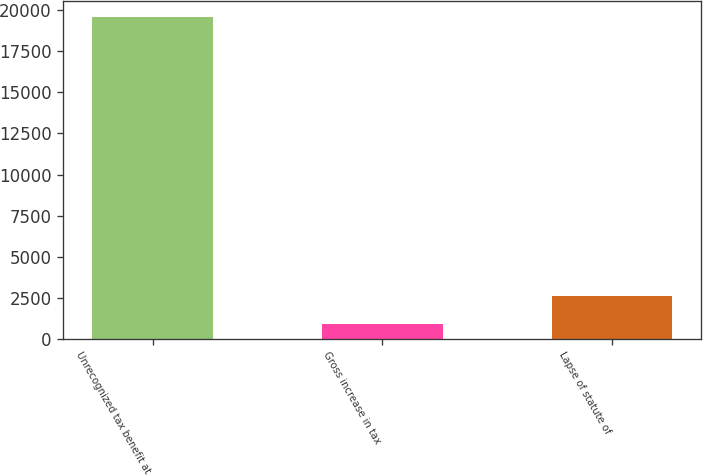Convert chart. <chart><loc_0><loc_0><loc_500><loc_500><bar_chart><fcel>Unrecognized tax benefit at<fcel>Gross increase in tax<fcel>Lapse of statute of<nl><fcel>19574.2<fcel>911<fcel>2608.2<nl></chart> 